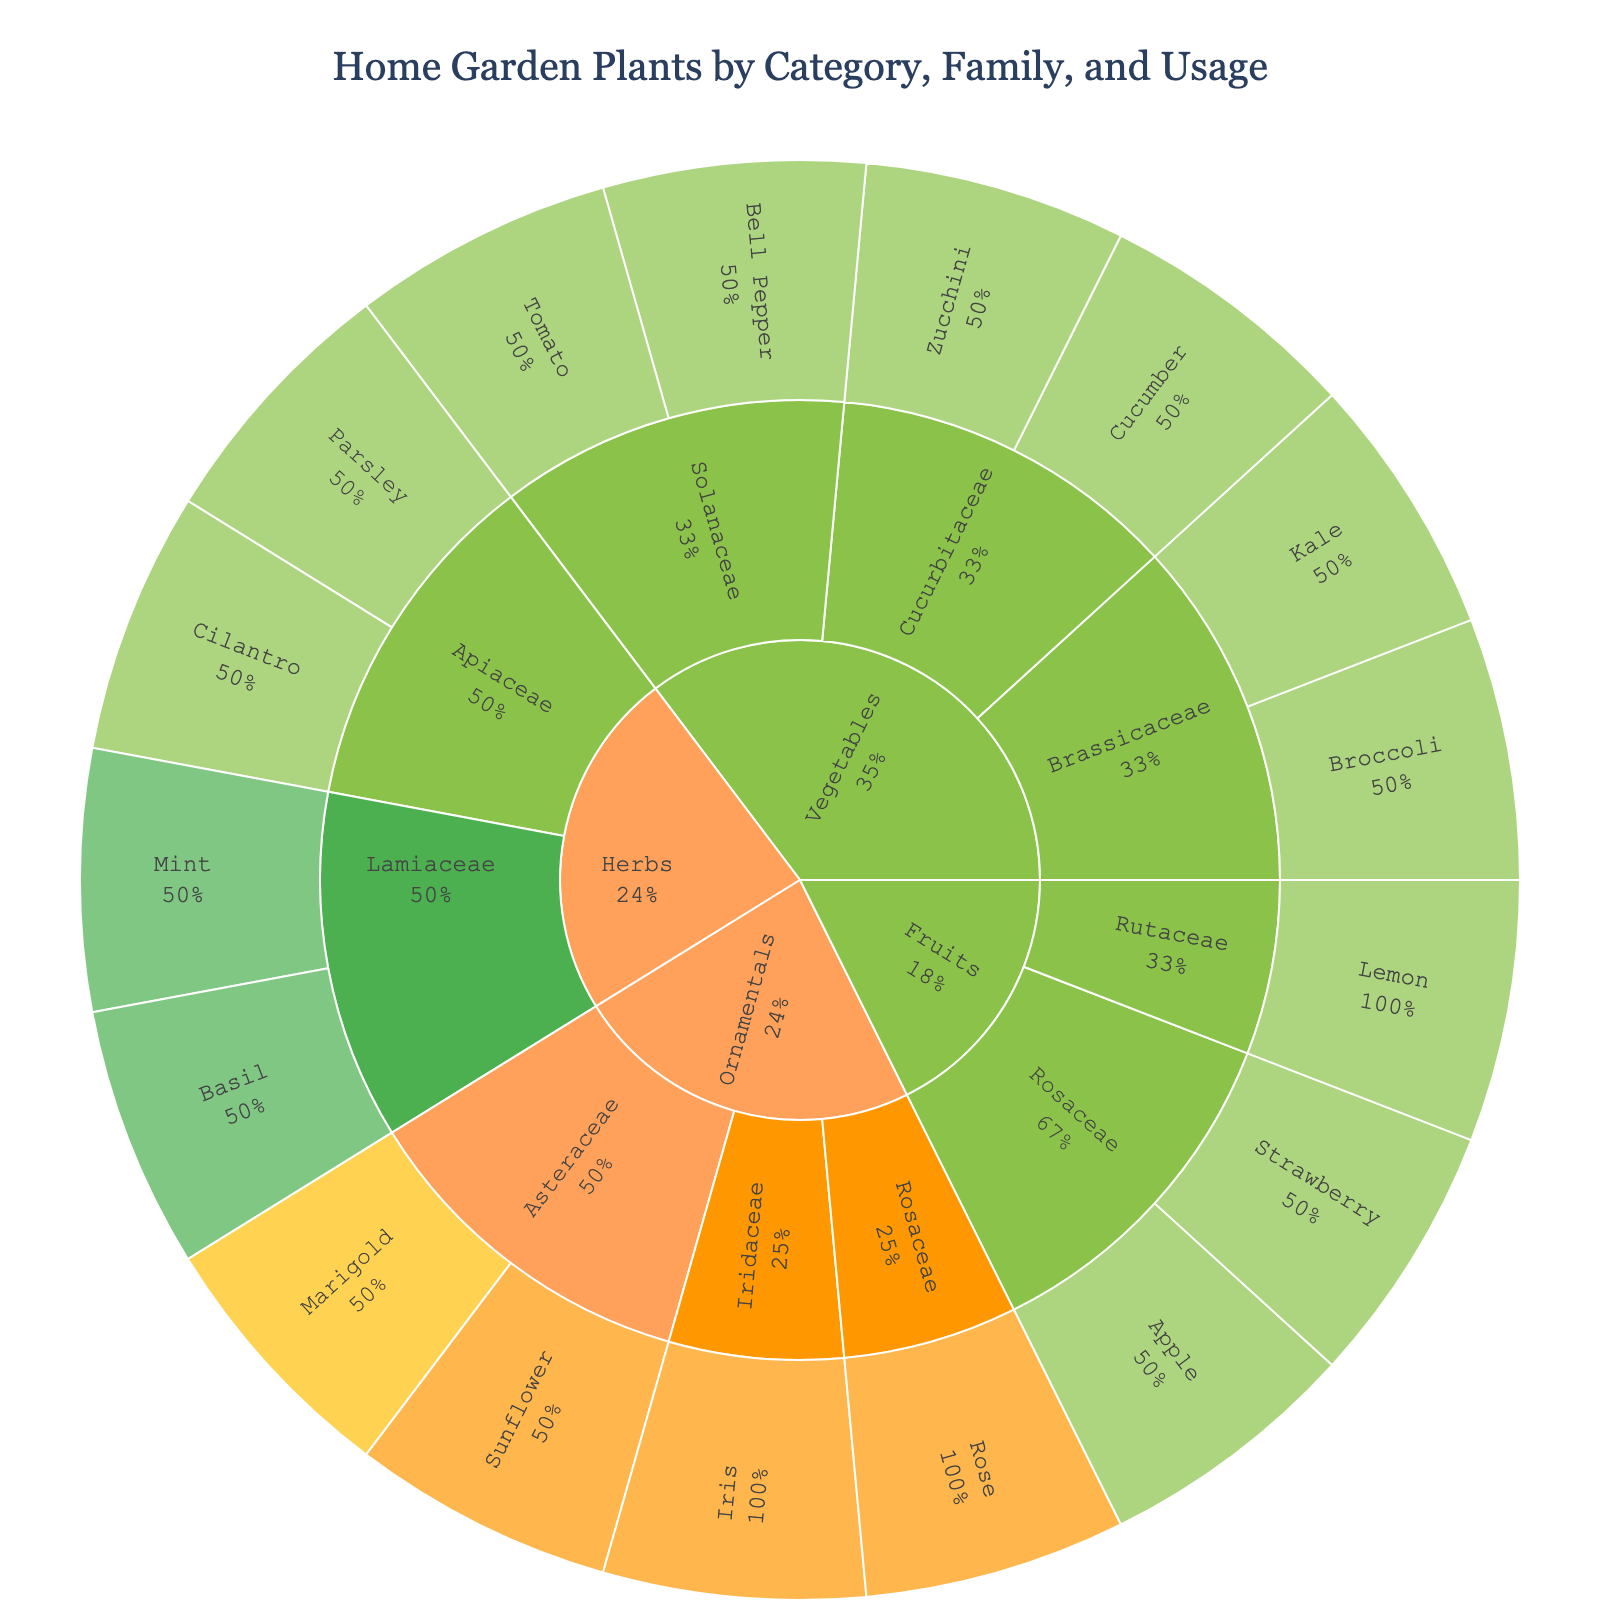How many plant families are visualized in the plot? The plot shows multiple layers, and each segment represents a plant family. Count the unique families listed.
Answer: 7 What is the most common usage for plants in the Solanaceae family? The Solanaceae family plants like Tomato and Bell Pepper are shown with the same color indicating their usage. Both are for Culinary purposes.
Answer: Culinary How many Ornamental plants are there and what are their usages? Look at the outer layer of the sunburst for the ‘Ornamentals’ category and count the plants listed. Check the segments’ colors to determine their usages. There are four ornamental plants: Marigold, Sunflower, Rose, and Iris. Marigold's usage is Decorative/Pest Control, while the others are Decorative.
Answer: 4, Decorative/Pest Control and Decorative Which category has the highest number of plant families? Review the plot sections for each category (Vegetables, Herbs, Fruits, Ornamentals) and count the unique families within each.
Answer: Vegetables What percentage of the Herbs category does the Lamiaceae family represent? Find the Herbs category segment and look at the Lamiaceae portion within it. The segment should provide a percentage value as part of its label.
Answer: 50% Which plant has dual usage and what are the usages? Scan the outer layer for any plants with more than one color to indicate multiple usages. Identify the specific plant and its listed usages.
Answer: Basil and Mint; Culinary and Medicinal How many plants in the Rosaceae family are primarily for Decorative use? Navigate to the Rosaceae family segment in the plot and count the plants that are colored according to Decorative usage.
Answer: 1 In which category do plants primarily have a Culinary/Medicinal usage? Observe the plot sections where plants with the Culinary/Medicinal color are located. Identify the overarching category these plants belong to.
Answer: Herbs Compare the number of plants in the Cucurbitaceae family with those in the Asteraceae family. Which family has more plants? Locate and count the plants in the Cucurbitaceae family first, then do the same for the Asteraceae family. Compare the numbers to determine which is larger.
Answer: Asteraceae Which category has the least diverse usage of its plants? Review the usage colors for each category and identify which category has the fewest different colors associated with it.
Answer: Fruits 